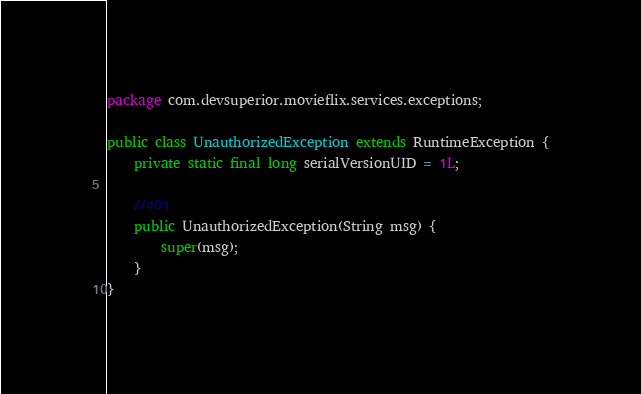<code> <loc_0><loc_0><loc_500><loc_500><_Java_>package com.devsuperior.movieflix.services.exceptions;

public class UnauthorizedException extends RuntimeException {
	private static final long serialVersionUID = 1L;
	
	//401
	public UnauthorizedException(String msg) {
		super(msg);
	}	
}

</code> 